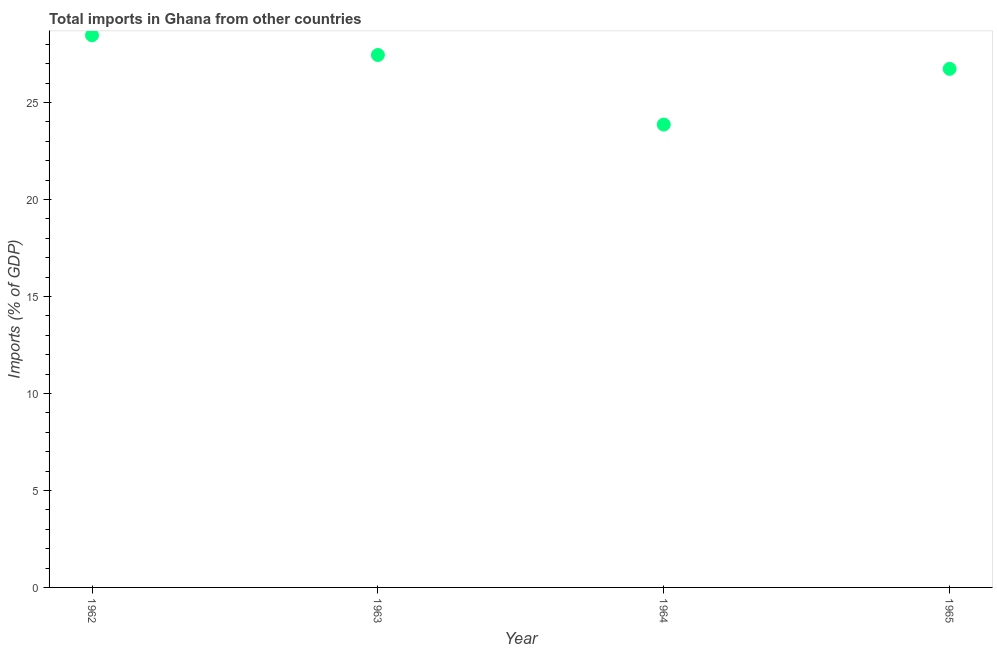What is the total imports in 1965?
Provide a short and direct response. 26.74. Across all years, what is the maximum total imports?
Give a very brief answer. 28.47. Across all years, what is the minimum total imports?
Your response must be concise. 23.87. In which year was the total imports maximum?
Offer a terse response. 1962. In which year was the total imports minimum?
Offer a terse response. 1964. What is the sum of the total imports?
Ensure brevity in your answer.  106.53. What is the difference between the total imports in 1963 and 1965?
Ensure brevity in your answer.  0.72. What is the average total imports per year?
Provide a succinct answer. 26.63. What is the median total imports?
Your answer should be compact. 27.1. In how many years, is the total imports greater than 23 %?
Your answer should be very brief. 4. What is the ratio of the total imports in 1962 to that in 1964?
Offer a very short reply. 1.19. Is the total imports in 1962 less than that in 1963?
Provide a succinct answer. No. Is the difference between the total imports in 1963 and 1964 greater than the difference between any two years?
Keep it short and to the point. No. What is the difference between the highest and the second highest total imports?
Provide a succinct answer. 1.02. Is the sum of the total imports in 1962 and 1963 greater than the maximum total imports across all years?
Ensure brevity in your answer.  Yes. What is the difference between the highest and the lowest total imports?
Keep it short and to the point. 4.6. In how many years, is the total imports greater than the average total imports taken over all years?
Offer a terse response. 3. Does the total imports monotonically increase over the years?
Ensure brevity in your answer.  No. How many years are there in the graph?
Offer a terse response. 4. Does the graph contain grids?
Keep it short and to the point. No. What is the title of the graph?
Provide a succinct answer. Total imports in Ghana from other countries. What is the label or title of the X-axis?
Your answer should be compact. Year. What is the label or title of the Y-axis?
Give a very brief answer. Imports (% of GDP). What is the Imports (% of GDP) in 1962?
Your response must be concise. 28.47. What is the Imports (% of GDP) in 1963?
Provide a short and direct response. 27.45. What is the Imports (% of GDP) in 1964?
Offer a very short reply. 23.87. What is the Imports (% of GDP) in 1965?
Ensure brevity in your answer.  26.74. What is the difference between the Imports (% of GDP) in 1962 and 1963?
Ensure brevity in your answer.  1.02. What is the difference between the Imports (% of GDP) in 1962 and 1964?
Your response must be concise. 4.6. What is the difference between the Imports (% of GDP) in 1962 and 1965?
Your answer should be very brief. 1.73. What is the difference between the Imports (% of GDP) in 1963 and 1964?
Provide a succinct answer. 3.59. What is the difference between the Imports (% of GDP) in 1963 and 1965?
Your answer should be very brief. 0.72. What is the difference between the Imports (% of GDP) in 1964 and 1965?
Offer a terse response. -2.87. What is the ratio of the Imports (% of GDP) in 1962 to that in 1963?
Make the answer very short. 1.04. What is the ratio of the Imports (% of GDP) in 1962 to that in 1964?
Provide a succinct answer. 1.19. What is the ratio of the Imports (% of GDP) in 1962 to that in 1965?
Make the answer very short. 1.06. What is the ratio of the Imports (% of GDP) in 1963 to that in 1964?
Ensure brevity in your answer.  1.15. What is the ratio of the Imports (% of GDP) in 1963 to that in 1965?
Provide a succinct answer. 1.03. What is the ratio of the Imports (% of GDP) in 1964 to that in 1965?
Your answer should be compact. 0.89. 